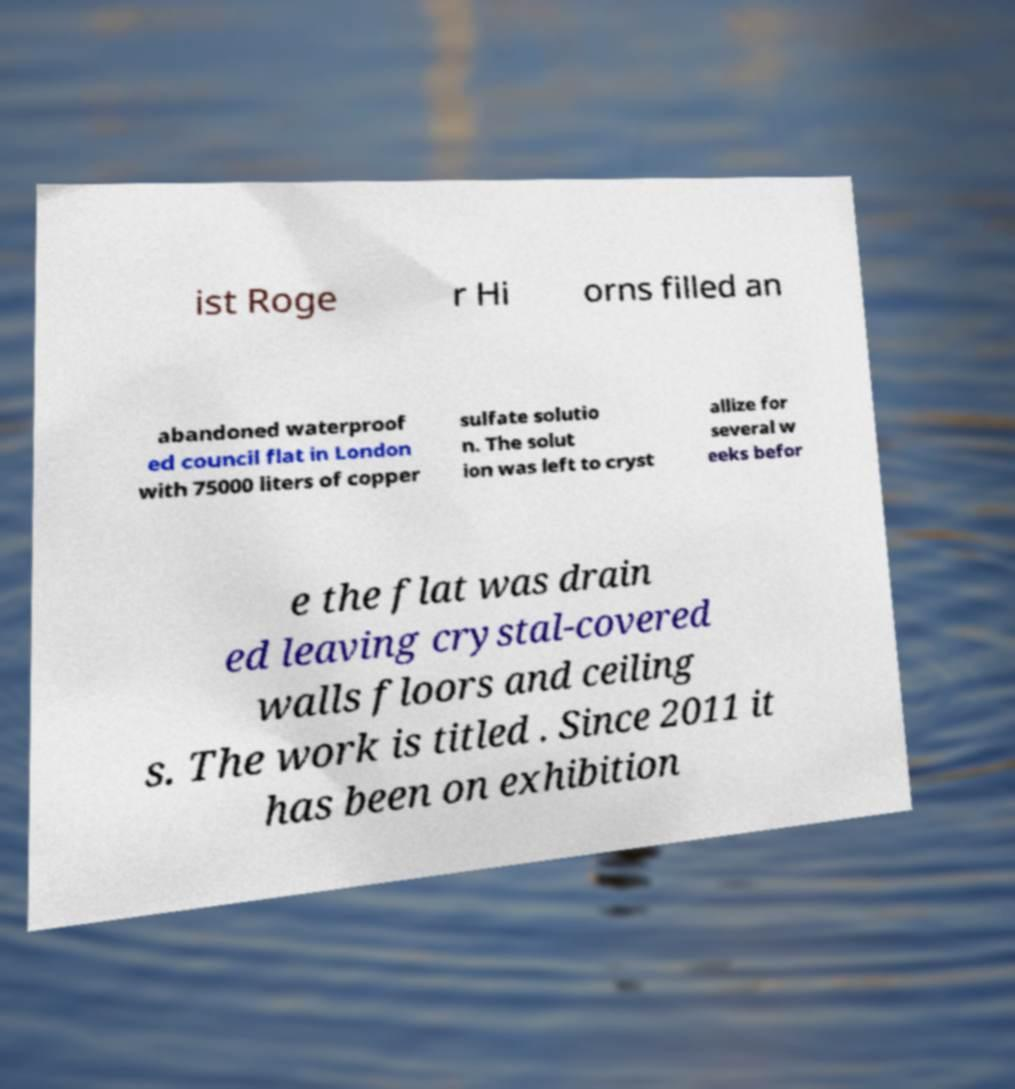There's text embedded in this image that I need extracted. Can you transcribe it verbatim? ist Roge r Hi orns filled an abandoned waterproof ed council flat in London with 75000 liters of copper sulfate solutio n. The solut ion was left to cryst allize for several w eeks befor e the flat was drain ed leaving crystal-covered walls floors and ceiling s. The work is titled . Since 2011 it has been on exhibition 